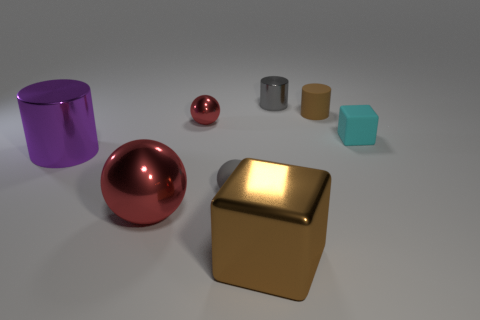The small rubber cube has what color?
Your response must be concise. Cyan. There is a block that is left of the small brown object; what size is it?
Offer a terse response. Large. There is a shiny cylinder that is to the left of the cylinder that is behind the tiny brown thing; how many large purple shiny things are right of it?
Your response must be concise. 0. What color is the big metallic thing behind the rubber object on the left side of the big cube?
Give a very brief answer. Purple. Is there a gray metallic cylinder of the same size as the rubber sphere?
Offer a terse response. Yes. There is a block to the left of the gray object behind the gray object in front of the brown rubber thing; what is its material?
Your response must be concise. Metal. How many small metallic cylinders are to the left of the small gray object left of the brown cube?
Provide a short and direct response. 0. There is a red ball that is behind the matte block; is its size the same as the big shiny cylinder?
Give a very brief answer. No. How many large red metal objects have the same shape as the gray matte object?
Provide a succinct answer. 1. The small gray matte object is what shape?
Ensure brevity in your answer.  Sphere. 